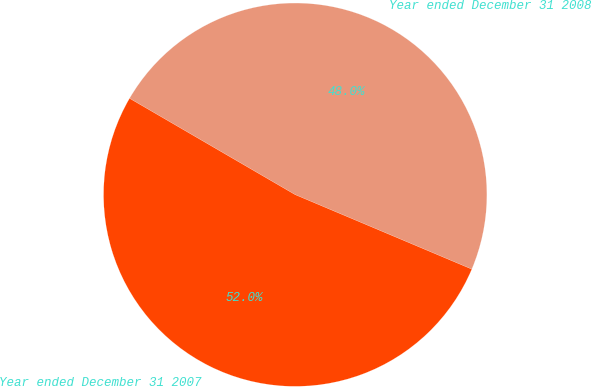Convert chart to OTSL. <chart><loc_0><loc_0><loc_500><loc_500><pie_chart><fcel>Year ended December 31 2008<fcel>Year ended December 31 2007<nl><fcel>47.97%<fcel>52.03%<nl></chart> 